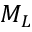Convert formula to latex. <formula><loc_0><loc_0><loc_500><loc_500>M _ { L }</formula> 